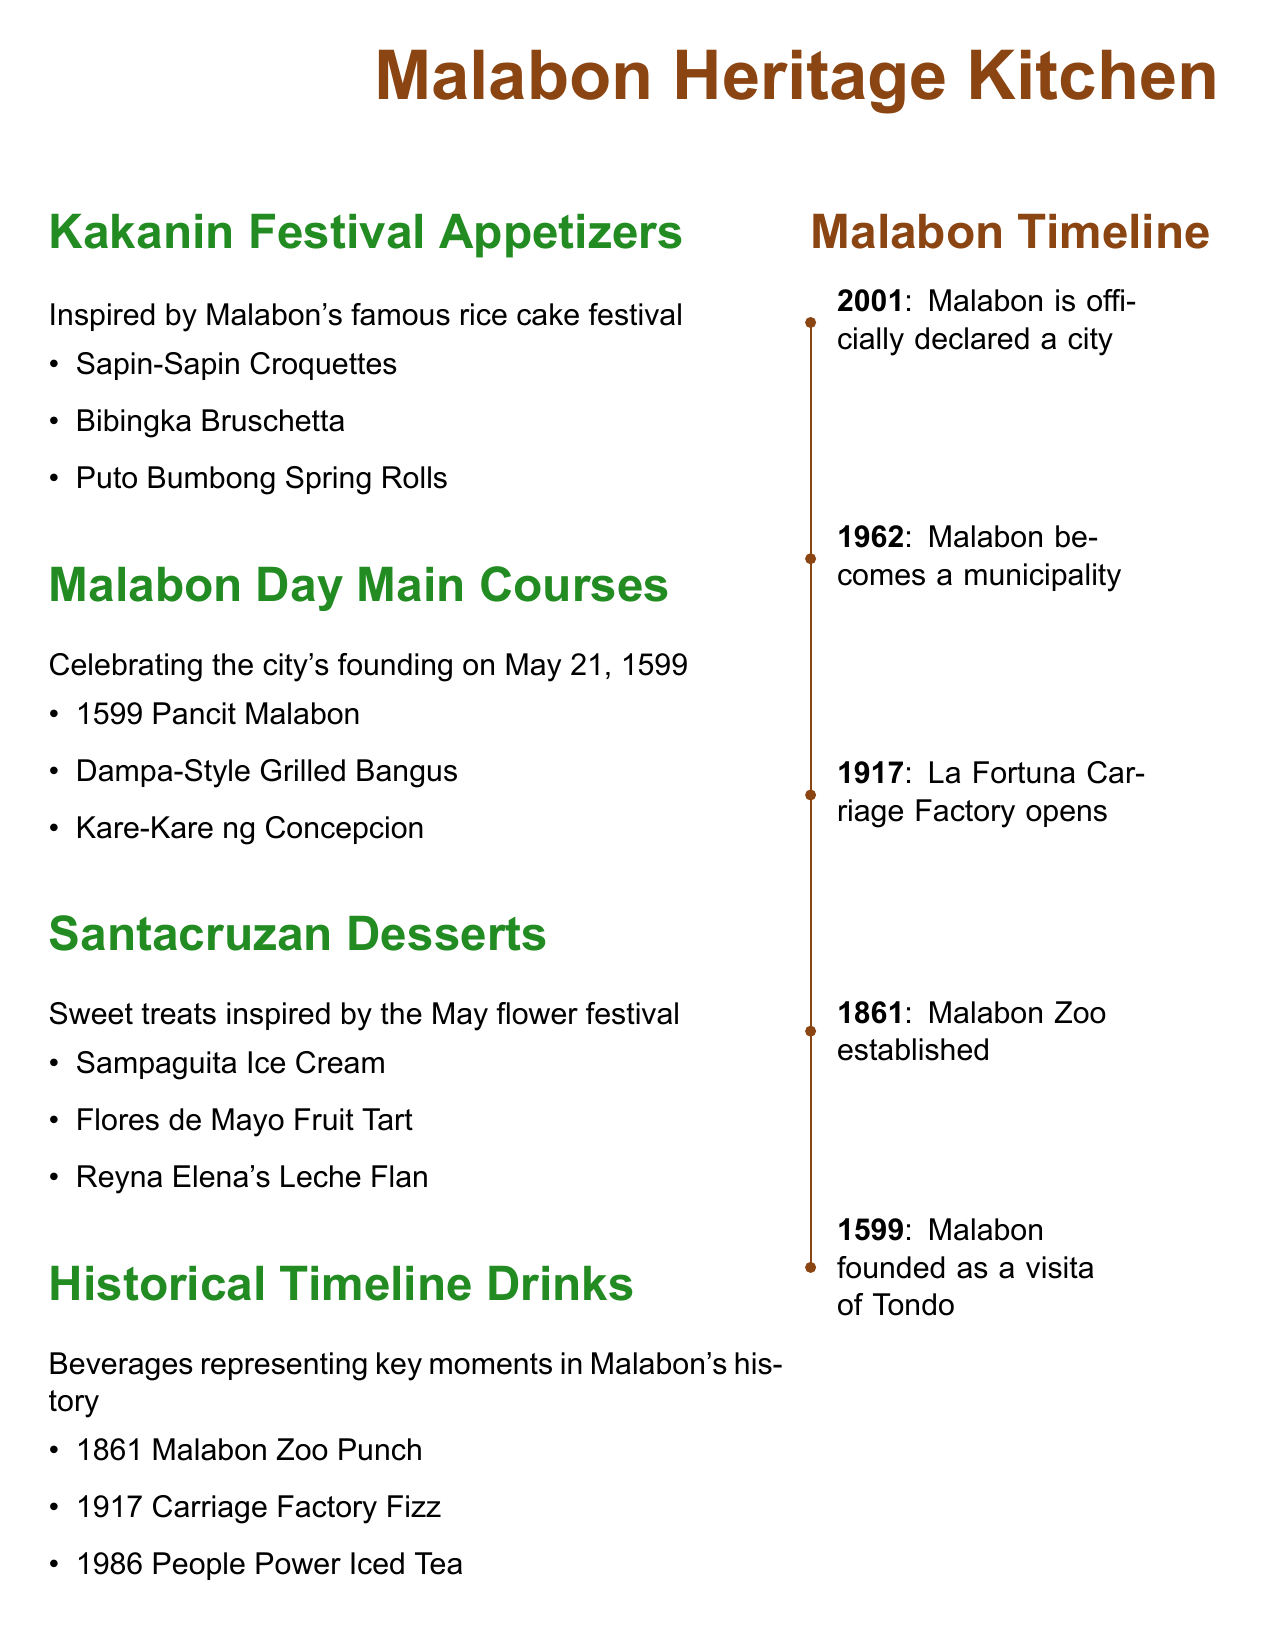What are the appetizers inspired by Malabon's festival? The appetizers listed are from the Kakanin Festival Appetizers section of the menu.
Answer: Sapin-Sapin Croquettes, Bibingka Bruschetta, Puto Bumbong Spring Rolls When was Malabon officially declared a city? The timeline notes that Malabon became a city in 2001.
Answer: 2001 What is the main course named after the city's founding year? The main courses include one specifically mentioned with the city's founding year in the title.
Answer: 1599 Pancit Malabon Which dessert represents the May flower festival? The desserts section lists treats inspired by the Santacruzan, which relates to the May flower festival.
Answer: Sampaguita Ice Cream What was established in Malabon in 1861? The historical timeline lists an event from 1861 related to Malabon.
Answer: Malabon Zoo How many main courses are featured in the Malabon Day section? The menu lists a total of three main courses under the Malabon Day section.
Answer: 3 What drink is associated with the year 1986? The drinks section highlights a beverage representing a significant event from 1986.
Answer: People Power Iced Tea What is the theme of the Kakanin Festival Appetizers? The theme for these appetizers celebrates a specific local festival.
Answer: Malabon's famous rice cake festival What type of menu is presented in this document? The structure and content suggest it is a specific type of culinary offering.
Answer: Seasonal menu 